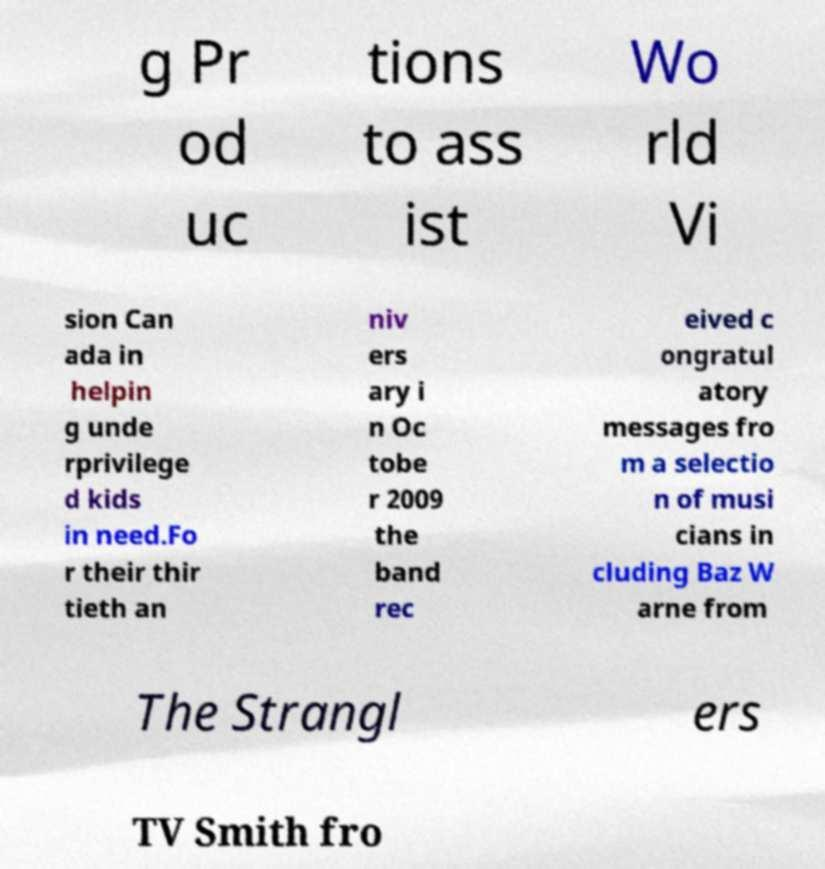There's text embedded in this image that I need extracted. Can you transcribe it verbatim? g Pr od uc tions to ass ist Wo rld Vi sion Can ada in helpin g unde rprivilege d kids in need.Fo r their thir tieth an niv ers ary i n Oc tobe r 2009 the band rec eived c ongratul atory messages fro m a selectio n of musi cians in cluding Baz W arne from The Strangl ers TV Smith fro 